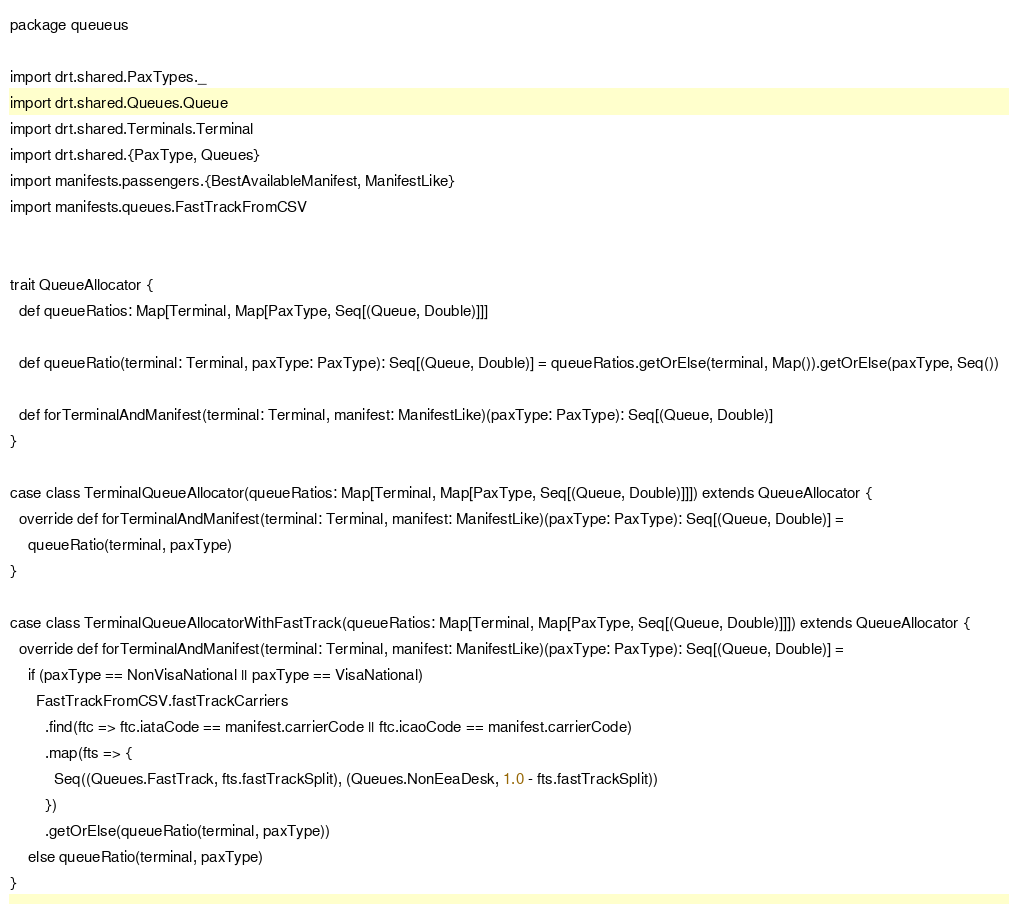Convert code to text. <code><loc_0><loc_0><loc_500><loc_500><_Scala_>package queueus

import drt.shared.PaxTypes._
import drt.shared.Queues.Queue
import drt.shared.Terminals.Terminal
import drt.shared.{PaxType, Queues}
import manifests.passengers.{BestAvailableManifest, ManifestLike}
import manifests.queues.FastTrackFromCSV


trait QueueAllocator {
  def queueRatios: Map[Terminal, Map[PaxType, Seq[(Queue, Double)]]]

  def queueRatio(terminal: Terminal, paxType: PaxType): Seq[(Queue, Double)] = queueRatios.getOrElse(terminal, Map()).getOrElse(paxType, Seq())

  def forTerminalAndManifest(terminal: Terminal, manifest: ManifestLike)(paxType: PaxType): Seq[(Queue, Double)]
}

case class TerminalQueueAllocator(queueRatios: Map[Terminal, Map[PaxType, Seq[(Queue, Double)]]]) extends QueueAllocator {
  override def forTerminalAndManifest(terminal: Terminal, manifest: ManifestLike)(paxType: PaxType): Seq[(Queue, Double)] =
    queueRatio(terminal, paxType)
}

case class TerminalQueueAllocatorWithFastTrack(queueRatios: Map[Terminal, Map[PaxType, Seq[(Queue, Double)]]]) extends QueueAllocator {
  override def forTerminalAndManifest(terminal: Terminal, manifest: ManifestLike)(paxType: PaxType): Seq[(Queue, Double)] =
    if (paxType == NonVisaNational || paxType == VisaNational)
      FastTrackFromCSV.fastTrackCarriers
        .find(ftc => ftc.iataCode == manifest.carrierCode || ftc.icaoCode == manifest.carrierCode)
        .map(fts => {
          Seq((Queues.FastTrack, fts.fastTrackSplit), (Queues.NonEeaDesk, 1.0 - fts.fastTrackSplit))
        })
        .getOrElse(queueRatio(terminal, paxType))
    else queueRatio(terminal, paxType)
}
</code> 